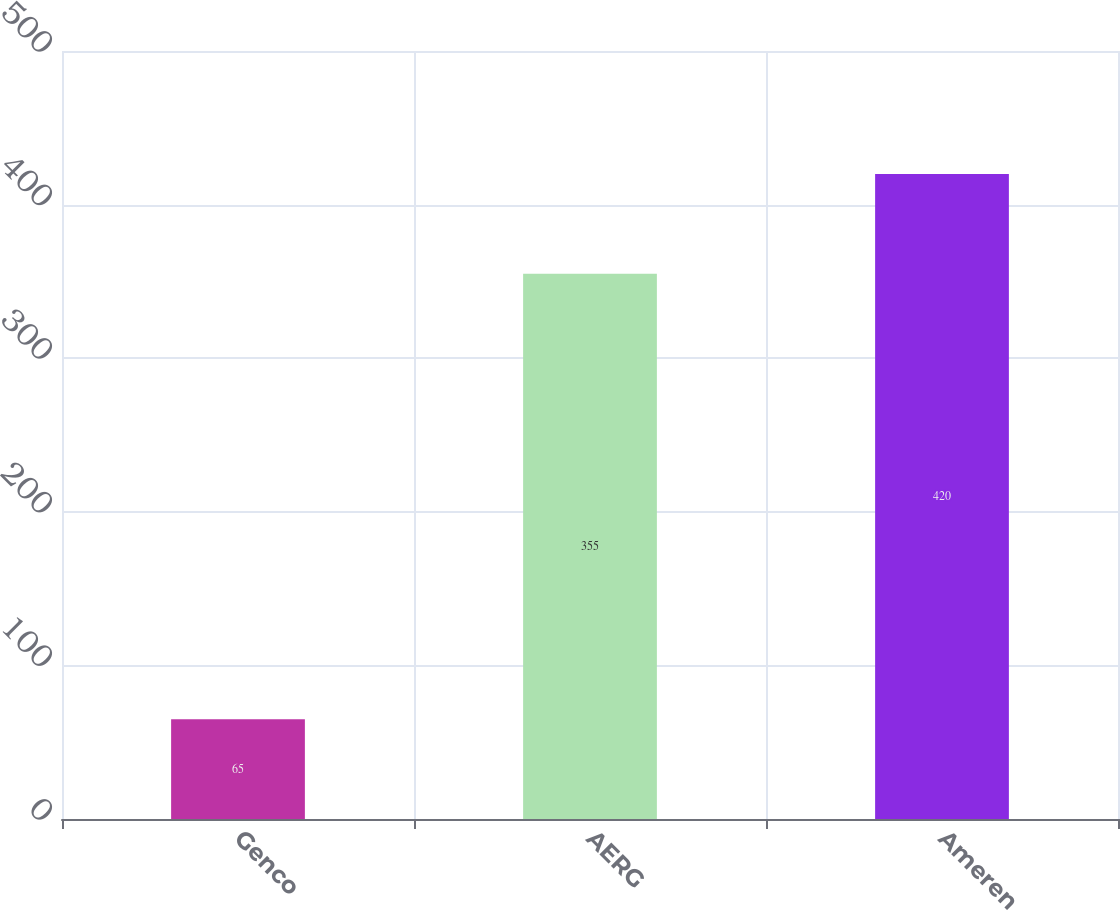Convert chart to OTSL. <chart><loc_0><loc_0><loc_500><loc_500><bar_chart><fcel>Genco<fcel>AERG<fcel>Ameren<nl><fcel>65<fcel>355<fcel>420<nl></chart> 